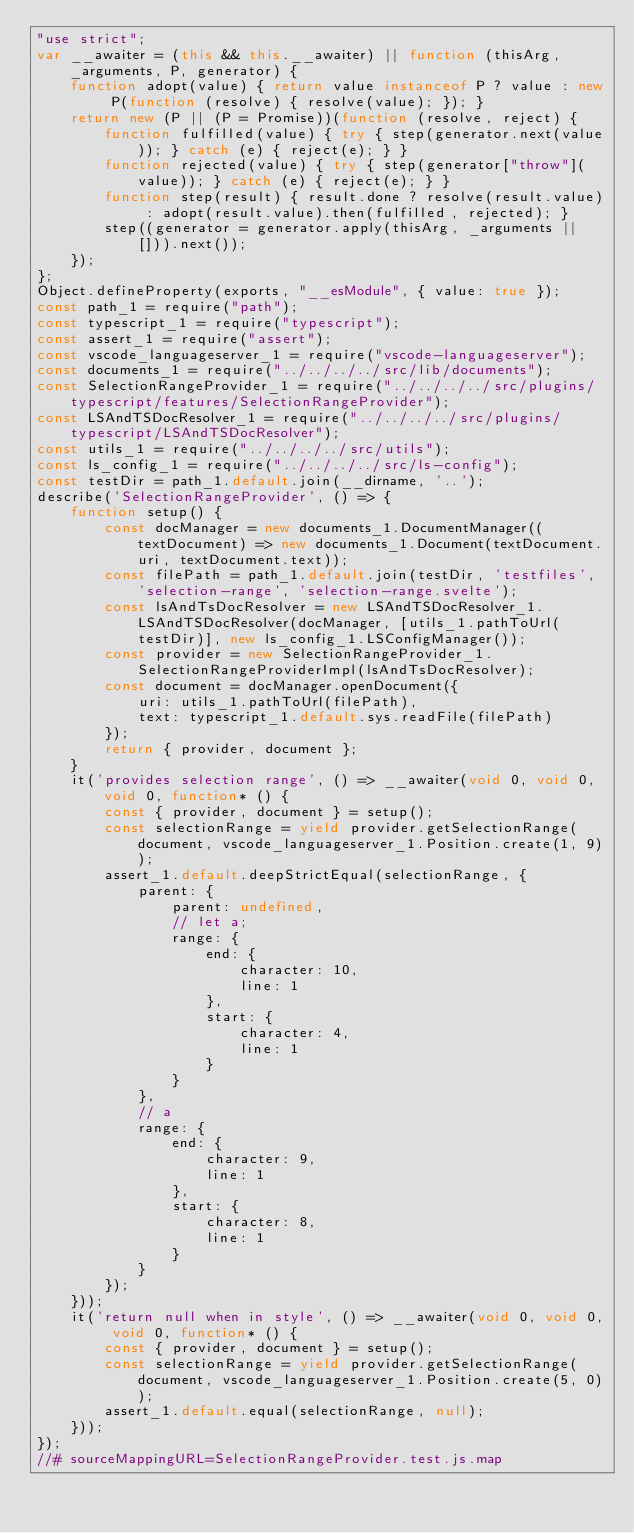<code> <loc_0><loc_0><loc_500><loc_500><_JavaScript_>"use strict";
var __awaiter = (this && this.__awaiter) || function (thisArg, _arguments, P, generator) {
    function adopt(value) { return value instanceof P ? value : new P(function (resolve) { resolve(value); }); }
    return new (P || (P = Promise))(function (resolve, reject) {
        function fulfilled(value) { try { step(generator.next(value)); } catch (e) { reject(e); } }
        function rejected(value) { try { step(generator["throw"](value)); } catch (e) { reject(e); } }
        function step(result) { result.done ? resolve(result.value) : adopt(result.value).then(fulfilled, rejected); }
        step((generator = generator.apply(thisArg, _arguments || [])).next());
    });
};
Object.defineProperty(exports, "__esModule", { value: true });
const path_1 = require("path");
const typescript_1 = require("typescript");
const assert_1 = require("assert");
const vscode_languageserver_1 = require("vscode-languageserver");
const documents_1 = require("../../../../src/lib/documents");
const SelectionRangeProvider_1 = require("../../../../src/plugins/typescript/features/SelectionRangeProvider");
const LSAndTSDocResolver_1 = require("../../../../src/plugins/typescript/LSAndTSDocResolver");
const utils_1 = require("../../../../src/utils");
const ls_config_1 = require("../../../../src/ls-config");
const testDir = path_1.default.join(__dirname, '..');
describe('SelectionRangeProvider', () => {
    function setup() {
        const docManager = new documents_1.DocumentManager((textDocument) => new documents_1.Document(textDocument.uri, textDocument.text));
        const filePath = path_1.default.join(testDir, 'testfiles', 'selection-range', 'selection-range.svelte');
        const lsAndTsDocResolver = new LSAndTSDocResolver_1.LSAndTSDocResolver(docManager, [utils_1.pathToUrl(testDir)], new ls_config_1.LSConfigManager());
        const provider = new SelectionRangeProvider_1.SelectionRangeProviderImpl(lsAndTsDocResolver);
        const document = docManager.openDocument({
            uri: utils_1.pathToUrl(filePath),
            text: typescript_1.default.sys.readFile(filePath)
        });
        return { provider, document };
    }
    it('provides selection range', () => __awaiter(void 0, void 0, void 0, function* () {
        const { provider, document } = setup();
        const selectionRange = yield provider.getSelectionRange(document, vscode_languageserver_1.Position.create(1, 9));
        assert_1.default.deepStrictEqual(selectionRange, {
            parent: {
                parent: undefined,
                // let a;
                range: {
                    end: {
                        character: 10,
                        line: 1
                    },
                    start: {
                        character: 4,
                        line: 1
                    }
                }
            },
            // a
            range: {
                end: {
                    character: 9,
                    line: 1
                },
                start: {
                    character: 8,
                    line: 1
                }
            }
        });
    }));
    it('return null when in style', () => __awaiter(void 0, void 0, void 0, function* () {
        const { provider, document } = setup();
        const selectionRange = yield provider.getSelectionRange(document, vscode_languageserver_1.Position.create(5, 0));
        assert_1.default.equal(selectionRange, null);
    }));
});
//# sourceMappingURL=SelectionRangeProvider.test.js.map</code> 